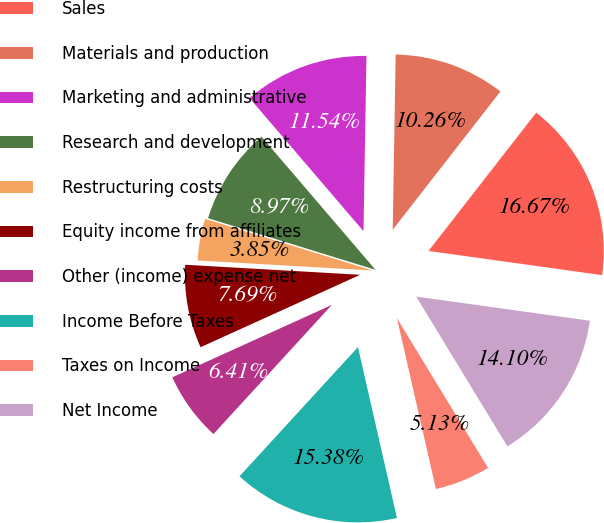<chart> <loc_0><loc_0><loc_500><loc_500><pie_chart><fcel>Sales<fcel>Materials and production<fcel>Marketing and administrative<fcel>Research and development<fcel>Restructuring costs<fcel>Equity income from affiliates<fcel>Other (income) expense net<fcel>Income Before Taxes<fcel>Taxes on Income<fcel>Net Income<nl><fcel>16.67%<fcel>10.26%<fcel>11.54%<fcel>8.97%<fcel>3.85%<fcel>7.69%<fcel>6.41%<fcel>15.38%<fcel>5.13%<fcel>14.1%<nl></chart> 